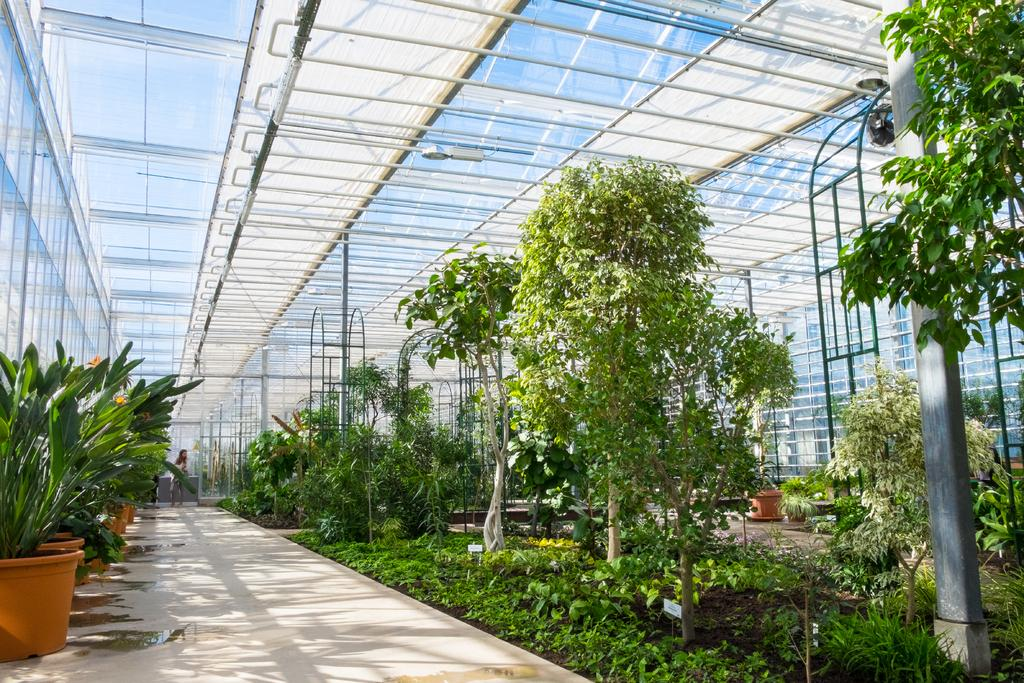What type of living organisms can be seen in the image? Plants and a person are visible in the image. What type of ground cover is present in the image? There is grass in the image. What is the person in the image doing? The person's actions are not specified, but they are present in the image. What type of structures can be seen in the image? There are poles in the image. What other objects can be found in the nursery setting? There are other objects in the nursery, but their specific details are not provided. How many mittens are being worn by the person in the image? There is no mention of mittens or any clothing items in the image, so it is impossible to determine if the person is wearing any. 